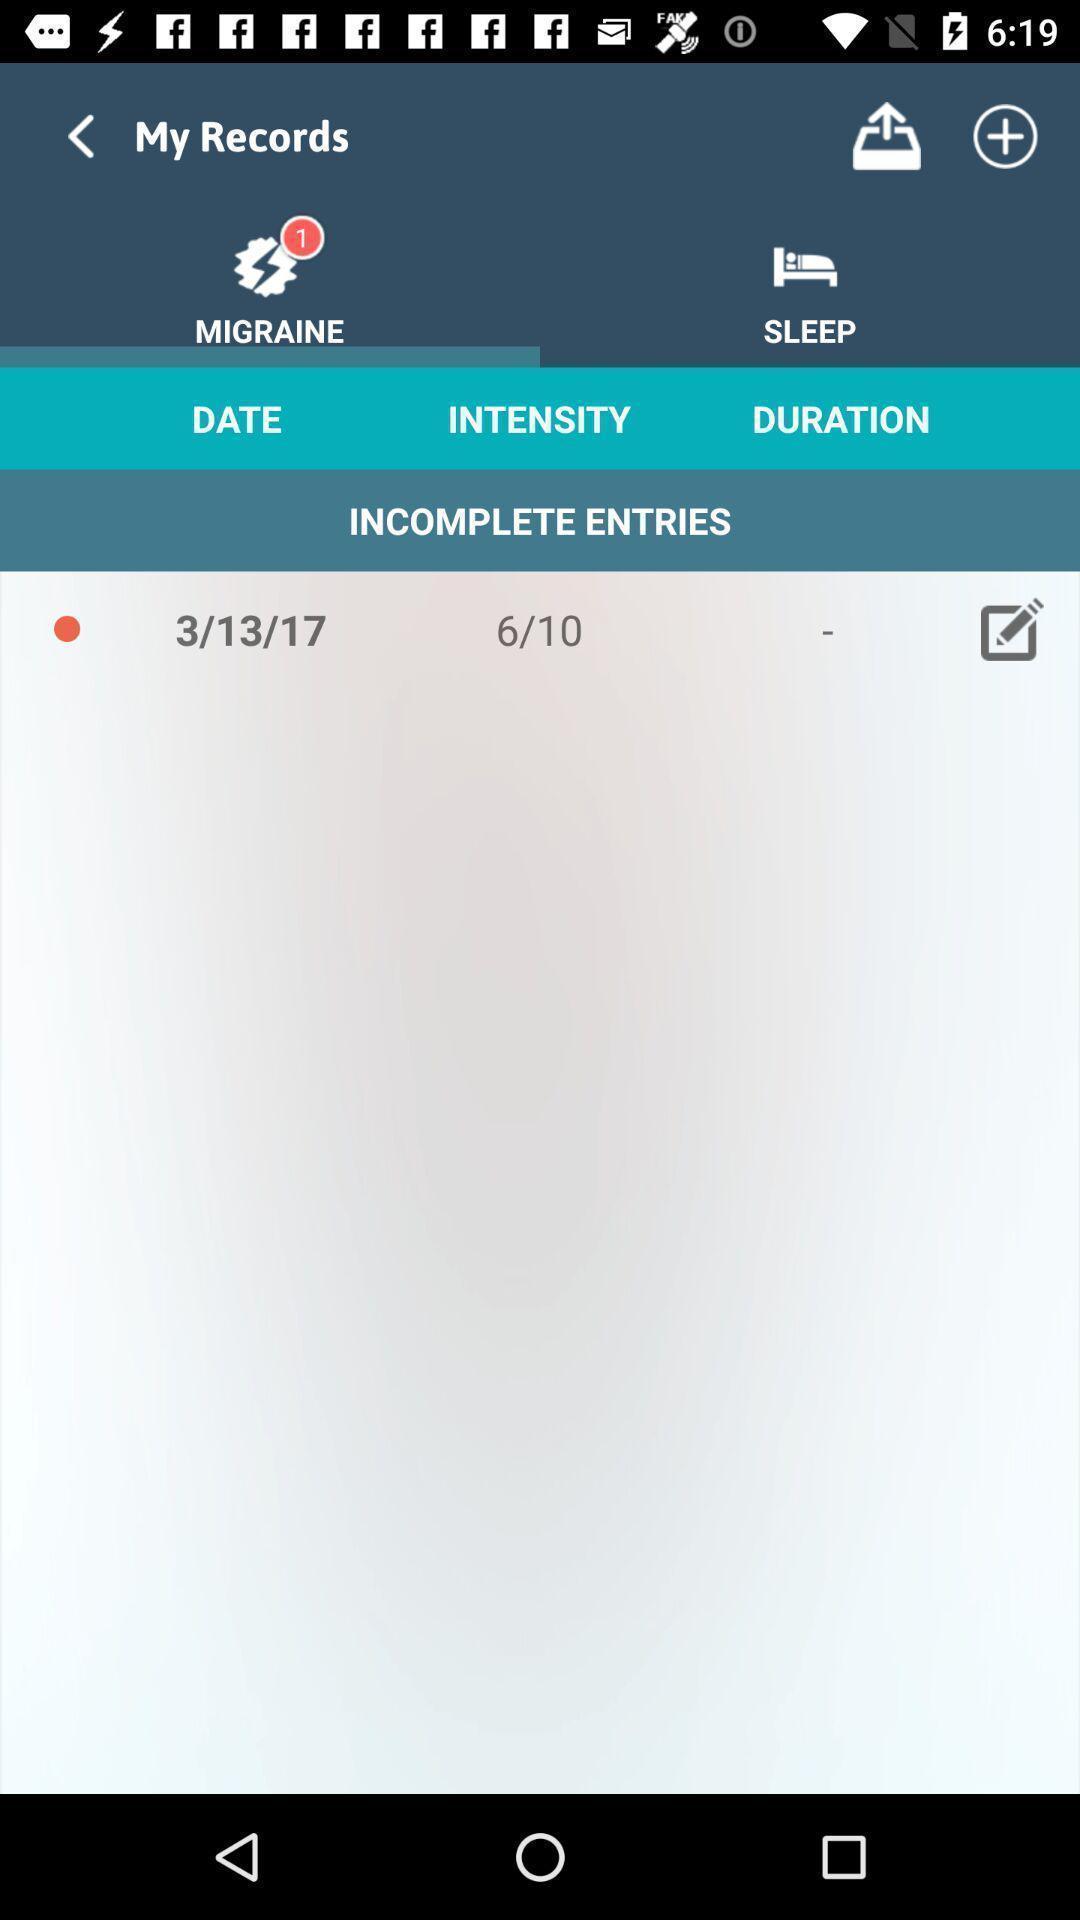Give me a summary of this screen capture. Screen shows multiple details. 